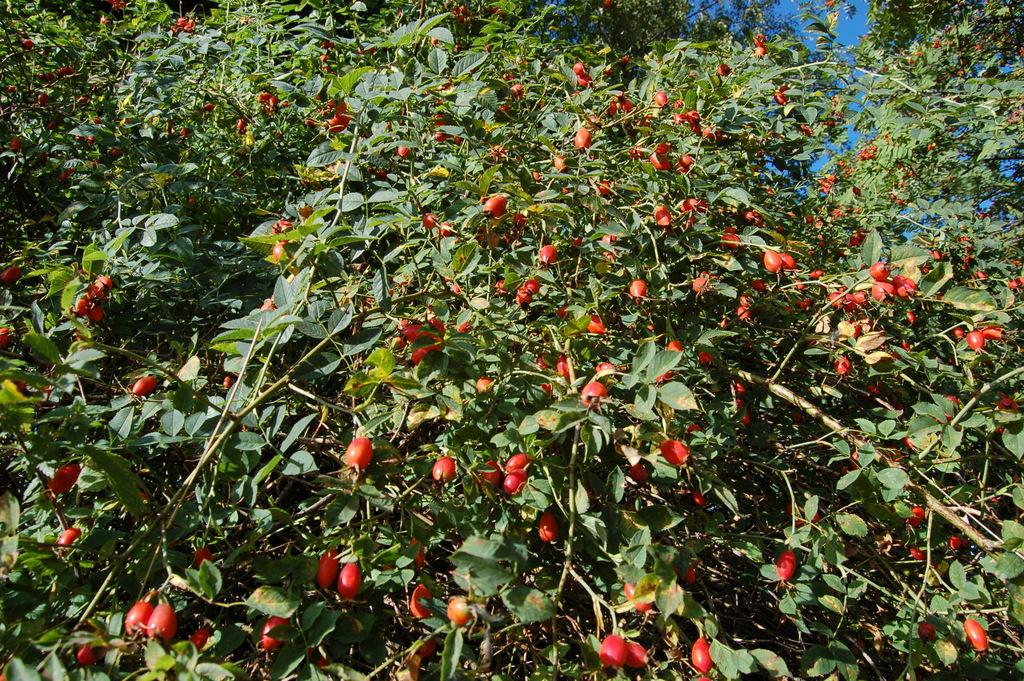What type of fruits are visible in the image? There are many rosehip fruits in the image. Where are the rosehip fruits located? The rosehip fruits are on the branches. What type of screw can be seen in the image? There is no screw present in the image; it features many rosehip fruits on branches. How many cattle are visible in the image? There are no cattle present in the image; it features many rosehip fruits on branches. 